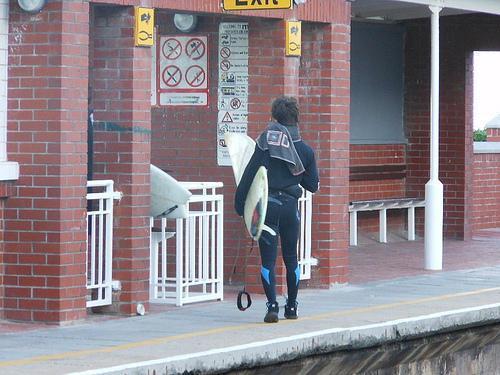How many people?
Give a very brief answer. 1. How many surfboards?
Give a very brief answer. 2. How many people are sitting down?
Give a very brief answer. 0. 